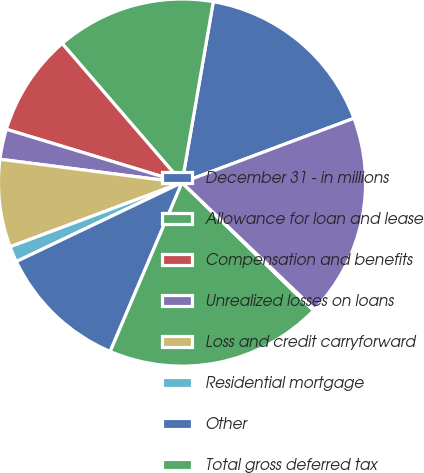Convert chart. <chart><loc_0><loc_0><loc_500><loc_500><pie_chart><fcel>December 31 - in millions<fcel>Allowance for loan and lease<fcel>Compensation and benefits<fcel>Unrealized losses on loans<fcel>Loss and credit carryforward<fcel>Residential mortgage<fcel>Other<fcel>Total gross deferred tax<fcel>Valuation allowance<fcel>Total deferred tax assets<nl><fcel>16.58%<fcel>14.05%<fcel>8.99%<fcel>2.66%<fcel>7.72%<fcel>1.39%<fcel>11.52%<fcel>19.12%<fcel>0.13%<fcel>17.85%<nl></chart> 